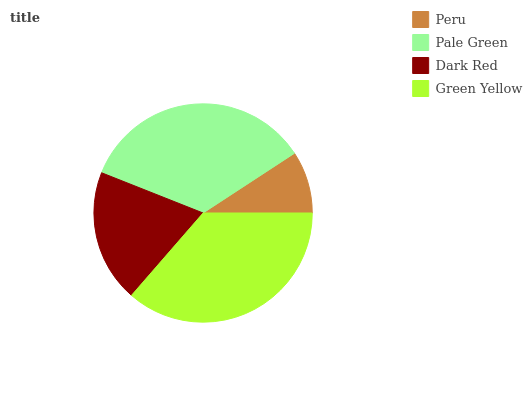Is Peru the minimum?
Answer yes or no. Yes. Is Green Yellow the maximum?
Answer yes or no. Yes. Is Pale Green the minimum?
Answer yes or no. No. Is Pale Green the maximum?
Answer yes or no. No. Is Pale Green greater than Peru?
Answer yes or no. Yes. Is Peru less than Pale Green?
Answer yes or no. Yes. Is Peru greater than Pale Green?
Answer yes or no. No. Is Pale Green less than Peru?
Answer yes or no. No. Is Pale Green the high median?
Answer yes or no. Yes. Is Dark Red the low median?
Answer yes or no. Yes. Is Dark Red the high median?
Answer yes or no. No. Is Green Yellow the low median?
Answer yes or no. No. 